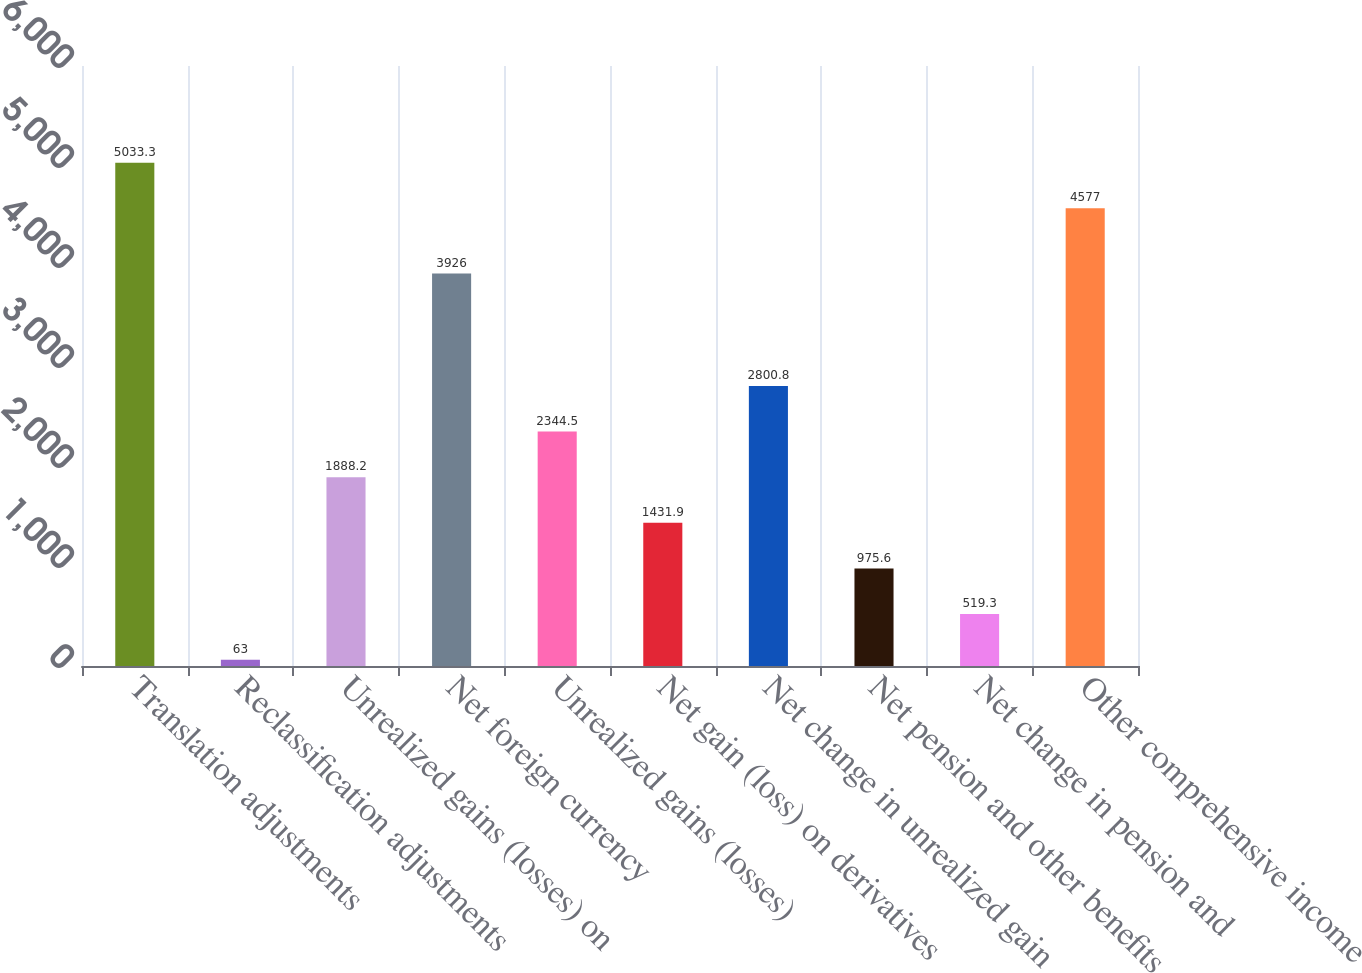Convert chart to OTSL. <chart><loc_0><loc_0><loc_500><loc_500><bar_chart><fcel>Translation adjustments<fcel>Reclassification adjustments<fcel>Unrealized gains (losses) on<fcel>Net foreign currency<fcel>Unrealized gains (losses)<fcel>Net gain (loss) on derivatives<fcel>Net change in unrealized gain<fcel>Net pension and other benefits<fcel>Net change in pension and<fcel>Other comprehensive income<nl><fcel>5033.3<fcel>63<fcel>1888.2<fcel>3926<fcel>2344.5<fcel>1431.9<fcel>2800.8<fcel>975.6<fcel>519.3<fcel>4577<nl></chart> 